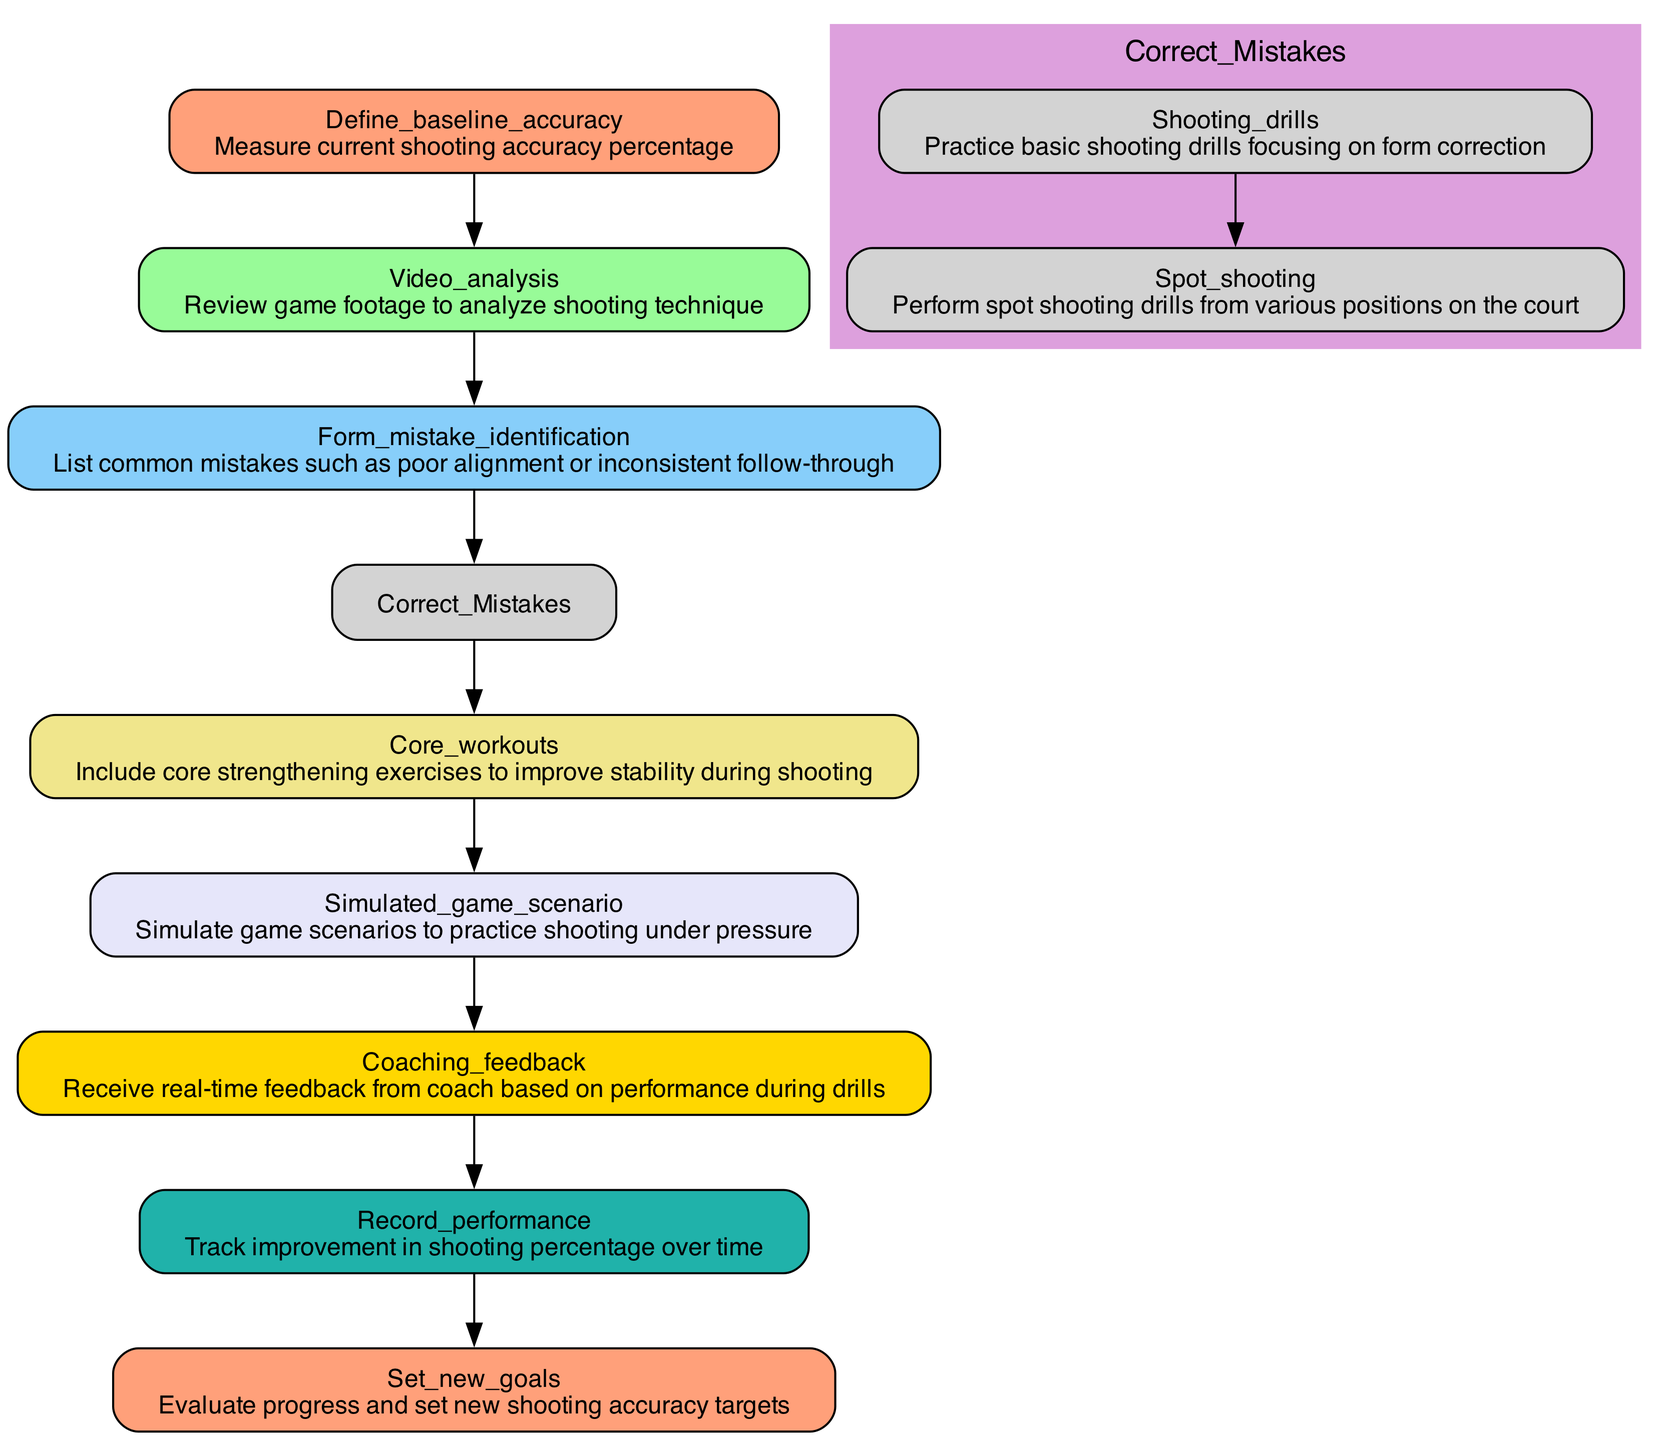What is the first action in the Shooting Accuracy Improvement Plan? The first action in the plan is defined in the "Start" node, which specifies measuring the current shooting accuracy percentage.
Answer: Define baseline accuracy How many main actions are there in the diagram? By counting the individual nodes representing main actions (e.g., Start, Analyze Form, Identify Mistakes, etc.), we can find there are 8 main actions.
Answer: 8 What action is taken after identifying mistakes in shooting form? After identifying mistakes, the next action involves correcting these mistakes, specified in the "Correct Mistakes" node.
Answer: Correct Mistakes What type of drills are included in the "Correct Mistakes" action? The "Correct Mistakes" action contains two types of drills: shooting drills and spot shooting drills. Both are aimed at form correction.
Answer: Shooting drills and spot shooting Which action focuses on enhancing core stability? The action that focuses on improving core stability is indicated in the "Strengthen Core" node.
Answer: Core workouts How is the feedback loop structured in the diagram? The feedback loop is structured by receiving real-time feedback from a coach based on performance during drills, which is specified in the "Feedback Loop" action.
Answer: Coaching feedback What is the final action in the Shooting Accuracy Improvement Plan? The final action in the plan is found in the "End" node, which is to evaluate progress and set new shooting accuracy targets.
Answer: Set new goals Which action involves simulated game scenarios? The action that involves simulated game scenarios for practicing shooting under pressure is named "Simulation Practice."
Answer: Simulated game scenario What are the indicators of improvement in shooting accuracy? The indicators of improvement are tracked through the "Track Progress" action, which records the performance and improvement in shooting percentage over time.
Answer: Record performance 